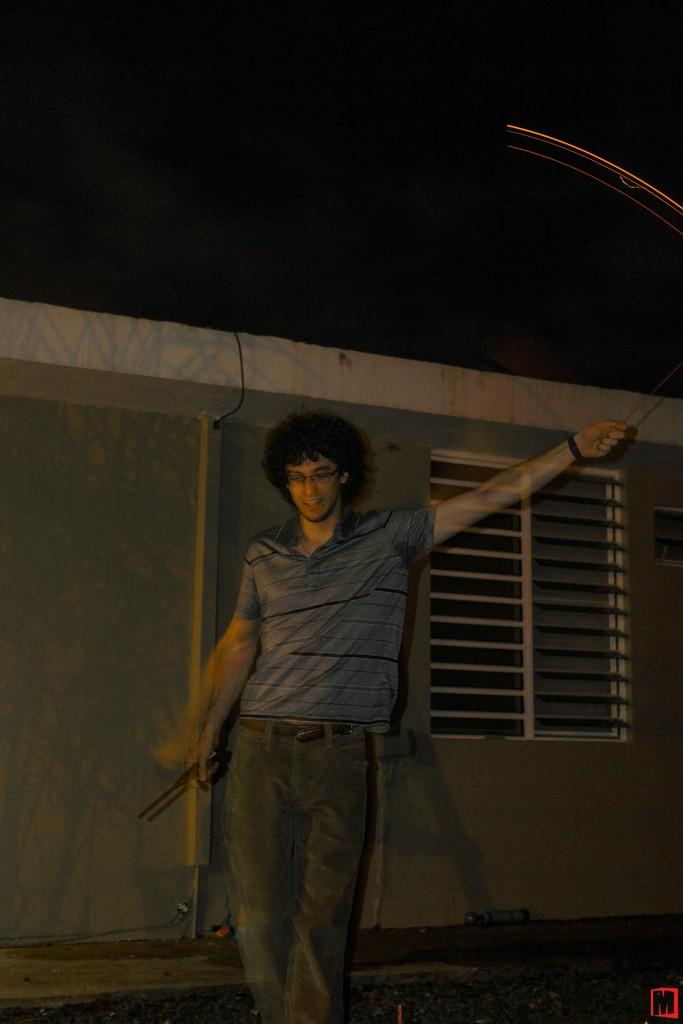What is the main subject of the image? There is a person standing in the center of the image. What is the person holding in the image? The person is holding an object. What can be seen in the background of the image? There is a wall and a window in the background of the image. What type of weather can be seen through the window in the image? There is no indication of weather in the image, as the window is not transparent enough to see through. 